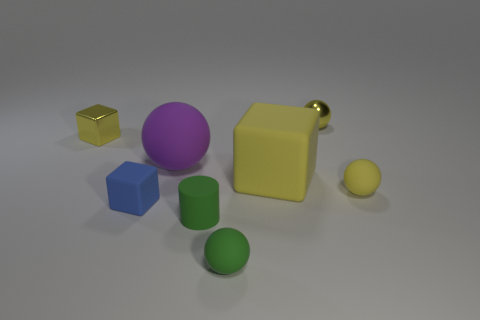How many objects are either green matte balls or tiny objects?
Your response must be concise. 6. Does the blue rubber block have the same size as the matte block that is on the right side of the tiny green matte cylinder?
Provide a short and direct response. No. What size is the yellow object that is right of the metal thing to the right of the blue rubber object that is to the left of the big purple matte thing?
Provide a short and direct response. Small. Is there a big gray block?
Keep it short and to the point. No. What is the material of the other block that is the same color as the big matte cube?
Ensure brevity in your answer.  Metal. What number of big matte objects are the same color as the metal block?
Provide a succinct answer. 1. How many things are either tiny things that are in front of the tiny shiny cube or tiny yellow things on the right side of the small blue rubber cube?
Your response must be concise. 5. What number of matte objects are in front of the small rubber object on the left side of the purple object?
Keep it short and to the point. 2. There is a big sphere that is the same material as the small green cylinder; what color is it?
Offer a terse response. Purple. Are there any other things of the same size as the purple matte thing?
Give a very brief answer. Yes. 